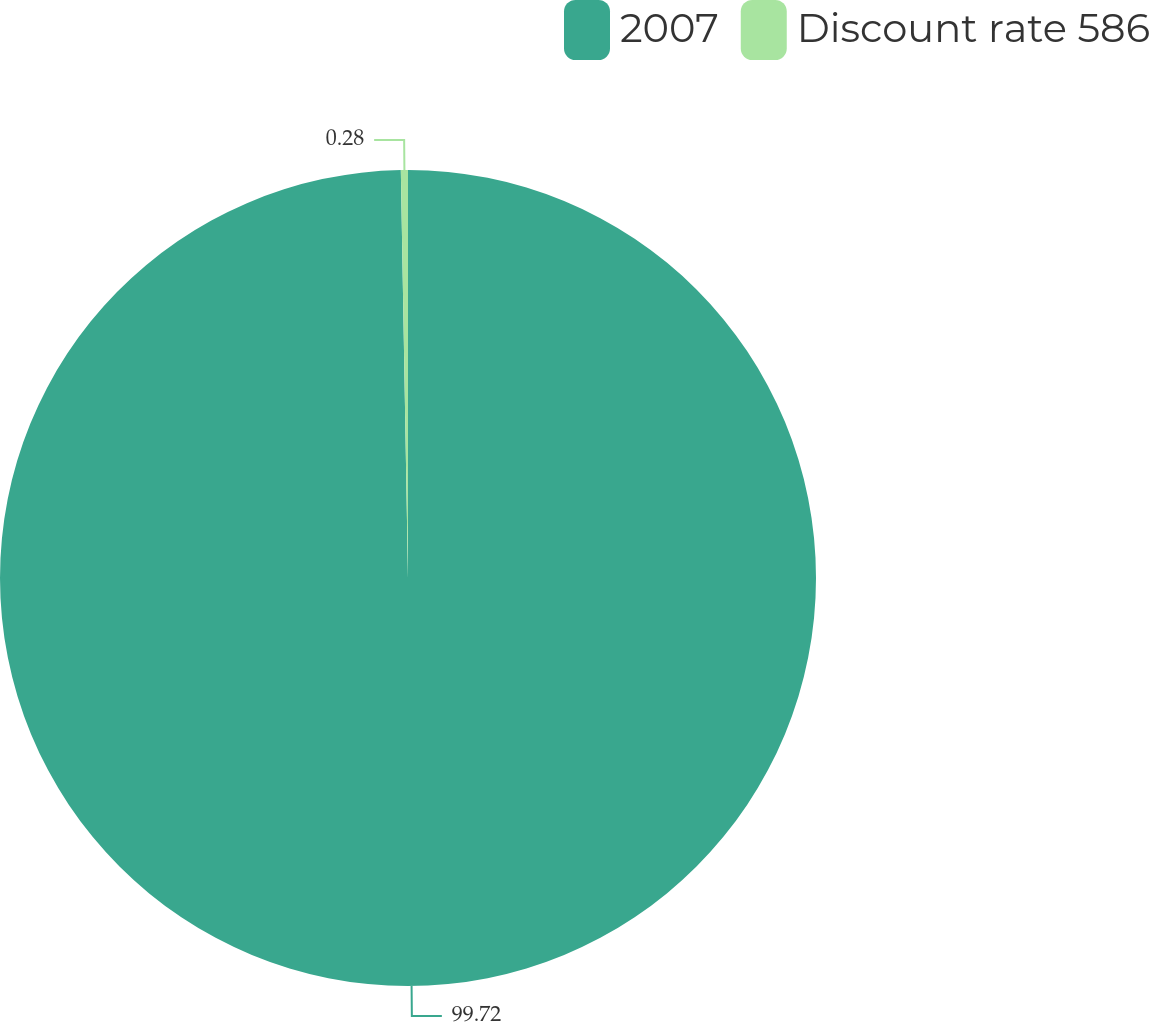<chart> <loc_0><loc_0><loc_500><loc_500><pie_chart><fcel>2007<fcel>Discount rate 586<nl><fcel>99.72%<fcel>0.28%<nl></chart> 